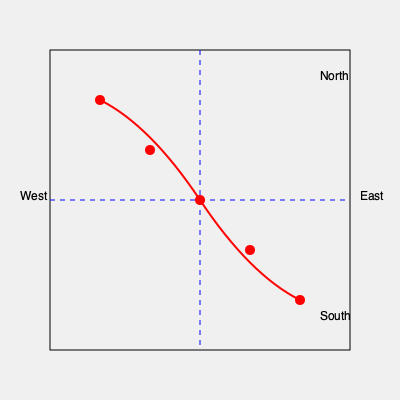Based on the animal migration pattern shown on the map, which general direction are the animals moving as the seasons change? To determine the general direction of animal migration, we need to analyze the pattern shown on the map:

1. Observe the red dots on the map, which represent animal sightings or tracking data points.
2. Notice that the dots form a curved line, indicating the path of migration.
3. The first dot (starting point) is located in the northwest quadrant of the map.
4. As we follow the dots, we can see that they progress towards the southeast quadrant of the map.
5. The curved line connecting the dots (red line) shows a clear movement from the northwest to the southeast.
6. The map is divided into four quadrants by blue dashed lines, helping us identify the cardinal directions.
7. The movement starts in the top-left (northwest) quadrant and ends in the bottom-right (southeast) quadrant.

Given this analysis, we can conclude that the general direction of the animal migration pattern is from northwest to southeast as the seasons change.
Answer: Northwest to Southeast 